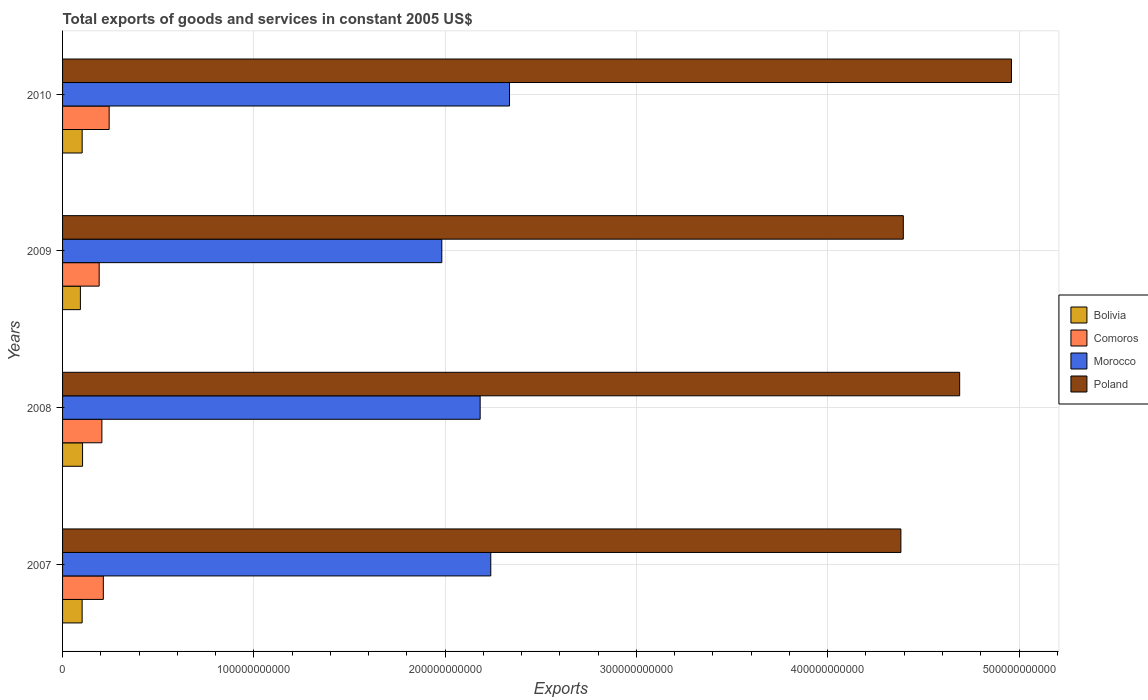How many different coloured bars are there?
Provide a short and direct response. 4. Are the number of bars per tick equal to the number of legend labels?
Offer a terse response. Yes. Are the number of bars on each tick of the Y-axis equal?
Make the answer very short. Yes. What is the label of the 3rd group of bars from the top?
Keep it short and to the point. 2008. What is the total exports of goods and services in Comoros in 2009?
Offer a very short reply. 1.91e+1. Across all years, what is the maximum total exports of goods and services in Comoros?
Give a very brief answer. 2.44e+1. Across all years, what is the minimum total exports of goods and services in Poland?
Keep it short and to the point. 4.38e+11. In which year was the total exports of goods and services in Comoros minimum?
Provide a short and direct response. 2009. What is the total total exports of goods and services in Bolivia in the graph?
Offer a very short reply. 4.03e+1. What is the difference between the total exports of goods and services in Bolivia in 2007 and that in 2008?
Your answer should be compact. -2.22e+08. What is the difference between the total exports of goods and services in Comoros in 2010 and the total exports of goods and services in Bolivia in 2007?
Provide a short and direct response. 1.41e+1. What is the average total exports of goods and services in Comoros per year?
Give a very brief answer. 2.13e+1. In the year 2010, what is the difference between the total exports of goods and services in Morocco and total exports of goods and services in Poland?
Offer a terse response. -2.62e+11. In how many years, is the total exports of goods and services in Poland greater than 160000000000 US$?
Give a very brief answer. 4. What is the ratio of the total exports of goods and services in Morocco in 2007 to that in 2009?
Make the answer very short. 1.13. Is the total exports of goods and services in Poland in 2007 less than that in 2010?
Ensure brevity in your answer.  Yes. Is the difference between the total exports of goods and services in Morocco in 2008 and 2009 greater than the difference between the total exports of goods and services in Poland in 2008 and 2009?
Ensure brevity in your answer.  No. What is the difference between the highest and the second highest total exports of goods and services in Bolivia?
Offer a terse response. 2.05e+08. What is the difference between the highest and the lowest total exports of goods and services in Comoros?
Your answer should be very brief. 5.22e+09. In how many years, is the total exports of goods and services in Morocco greater than the average total exports of goods and services in Morocco taken over all years?
Make the answer very short. 2. Is it the case that in every year, the sum of the total exports of goods and services in Bolivia and total exports of goods and services in Poland is greater than the sum of total exports of goods and services in Comoros and total exports of goods and services in Morocco?
Ensure brevity in your answer.  No. What does the 3rd bar from the top in 2009 represents?
Ensure brevity in your answer.  Comoros. What does the 3rd bar from the bottom in 2008 represents?
Your answer should be very brief. Morocco. How many bars are there?
Your response must be concise. 16. How many years are there in the graph?
Give a very brief answer. 4. What is the difference between two consecutive major ticks on the X-axis?
Keep it short and to the point. 1.00e+11. Are the values on the major ticks of X-axis written in scientific E-notation?
Offer a terse response. No. Does the graph contain any zero values?
Your answer should be very brief. No. Where does the legend appear in the graph?
Ensure brevity in your answer.  Center right. How many legend labels are there?
Your answer should be compact. 4. What is the title of the graph?
Keep it short and to the point. Total exports of goods and services in constant 2005 US$. Does "Croatia" appear as one of the legend labels in the graph?
Ensure brevity in your answer.  No. What is the label or title of the X-axis?
Your response must be concise. Exports. What is the label or title of the Y-axis?
Provide a short and direct response. Years. What is the Exports in Bolivia in 2007?
Make the answer very short. 1.02e+1. What is the Exports of Comoros in 2007?
Offer a very short reply. 2.13e+1. What is the Exports in Morocco in 2007?
Offer a terse response. 2.24e+11. What is the Exports in Poland in 2007?
Provide a short and direct response. 4.38e+11. What is the Exports of Bolivia in 2008?
Give a very brief answer. 1.05e+1. What is the Exports of Comoros in 2008?
Offer a very short reply. 2.06e+1. What is the Exports in Morocco in 2008?
Provide a succinct answer. 2.18e+11. What is the Exports of Poland in 2008?
Provide a succinct answer. 4.69e+11. What is the Exports of Bolivia in 2009?
Offer a terse response. 9.33e+09. What is the Exports in Comoros in 2009?
Your answer should be very brief. 1.91e+1. What is the Exports in Morocco in 2009?
Provide a succinct answer. 1.98e+11. What is the Exports of Poland in 2009?
Provide a succinct answer. 4.40e+11. What is the Exports of Bolivia in 2010?
Your response must be concise. 1.02e+1. What is the Exports in Comoros in 2010?
Provide a succinct answer. 2.44e+1. What is the Exports of Morocco in 2010?
Provide a succinct answer. 2.34e+11. What is the Exports in Poland in 2010?
Offer a terse response. 4.96e+11. Across all years, what is the maximum Exports in Bolivia?
Ensure brevity in your answer.  1.05e+1. Across all years, what is the maximum Exports in Comoros?
Offer a terse response. 2.44e+1. Across all years, what is the maximum Exports in Morocco?
Your answer should be very brief. 2.34e+11. Across all years, what is the maximum Exports in Poland?
Provide a succinct answer. 4.96e+11. Across all years, what is the minimum Exports of Bolivia?
Make the answer very short. 9.33e+09. Across all years, what is the minimum Exports of Comoros?
Your answer should be compact. 1.91e+1. Across all years, what is the minimum Exports in Morocco?
Your answer should be compact. 1.98e+11. Across all years, what is the minimum Exports of Poland?
Offer a very short reply. 4.38e+11. What is the total Exports of Bolivia in the graph?
Make the answer very short. 4.03e+1. What is the total Exports of Comoros in the graph?
Give a very brief answer. 8.54e+1. What is the total Exports in Morocco in the graph?
Keep it short and to the point. 8.74e+11. What is the total Exports in Poland in the graph?
Give a very brief answer. 1.84e+12. What is the difference between the Exports of Bolivia in 2007 and that in 2008?
Offer a very short reply. -2.22e+08. What is the difference between the Exports of Comoros in 2007 and that in 2008?
Ensure brevity in your answer.  7.52e+08. What is the difference between the Exports in Morocco in 2007 and that in 2008?
Your answer should be very brief. 5.55e+09. What is the difference between the Exports of Poland in 2007 and that in 2008?
Your response must be concise. -3.07e+1. What is the difference between the Exports in Bolivia in 2007 and that in 2009?
Offer a terse response. 9.02e+08. What is the difference between the Exports in Comoros in 2007 and that in 2009?
Give a very brief answer. 2.17e+09. What is the difference between the Exports in Morocco in 2007 and that in 2009?
Offer a very short reply. 2.56e+1. What is the difference between the Exports in Poland in 2007 and that in 2009?
Provide a succinct answer. -1.27e+09. What is the difference between the Exports in Bolivia in 2007 and that in 2010?
Keep it short and to the point. -1.73e+07. What is the difference between the Exports of Comoros in 2007 and that in 2010?
Offer a very short reply. -3.05e+09. What is the difference between the Exports of Morocco in 2007 and that in 2010?
Your response must be concise. -9.80e+09. What is the difference between the Exports in Poland in 2007 and that in 2010?
Your response must be concise. -5.78e+1. What is the difference between the Exports in Bolivia in 2008 and that in 2009?
Make the answer very short. 1.12e+09. What is the difference between the Exports of Comoros in 2008 and that in 2009?
Your answer should be very brief. 1.42e+09. What is the difference between the Exports of Morocco in 2008 and that in 2009?
Make the answer very short. 2.00e+1. What is the difference between the Exports of Poland in 2008 and that in 2009?
Provide a succinct answer. 2.95e+1. What is the difference between the Exports in Bolivia in 2008 and that in 2010?
Make the answer very short. 2.05e+08. What is the difference between the Exports in Comoros in 2008 and that in 2010?
Your response must be concise. -3.80e+09. What is the difference between the Exports in Morocco in 2008 and that in 2010?
Provide a succinct answer. -1.53e+1. What is the difference between the Exports in Poland in 2008 and that in 2010?
Offer a terse response. -2.71e+1. What is the difference between the Exports in Bolivia in 2009 and that in 2010?
Provide a succinct answer. -9.19e+08. What is the difference between the Exports in Comoros in 2009 and that in 2010?
Provide a succinct answer. -5.22e+09. What is the difference between the Exports of Morocco in 2009 and that in 2010?
Give a very brief answer. -3.54e+1. What is the difference between the Exports in Poland in 2009 and that in 2010?
Keep it short and to the point. -5.65e+1. What is the difference between the Exports in Bolivia in 2007 and the Exports in Comoros in 2008?
Your answer should be very brief. -1.03e+1. What is the difference between the Exports of Bolivia in 2007 and the Exports of Morocco in 2008?
Keep it short and to the point. -2.08e+11. What is the difference between the Exports in Bolivia in 2007 and the Exports in Poland in 2008?
Make the answer very short. -4.59e+11. What is the difference between the Exports of Comoros in 2007 and the Exports of Morocco in 2008?
Give a very brief answer. -1.97e+11. What is the difference between the Exports of Comoros in 2007 and the Exports of Poland in 2008?
Offer a terse response. -4.48e+11. What is the difference between the Exports of Morocco in 2007 and the Exports of Poland in 2008?
Make the answer very short. -2.45e+11. What is the difference between the Exports of Bolivia in 2007 and the Exports of Comoros in 2009?
Make the answer very short. -8.91e+09. What is the difference between the Exports of Bolivia in 2007 and the Exports of Morocco in 2009?
Provide a succinct answer. -1.88e+11. What is the difference between the Exports of Bolivia in 2007 and the Exports of Poland in 2009?
Your answer should be very brief. -4.29e+11. What is the difference between the Exports of Comoros in 2007 and the Exports of Morocco in 2009?
Keep it short and to the point. -1.77e+11. What is the difference between the Exports of Comoros in 2007 and the Exports of Poland in 2009?
Provide a succinct answer. -4.18e+11. What is the difference between the Exports in Morocco in 2007 and the Exports in Poland in 2009?
Ensure brevity in your answer.  -2.16e+11. What is the difference between the Exports in Bolivia in 2007 and the Exports in Comoros in 2010?
Your response must be concise. -1.41e+1. What is the difference between the Exports in Bolivia in 2007 and the Exports in Morocco in 2010?
Your response must be concise. -2.23e+11. What is the difference between the Exports in Bolivia in 2007 and the Exports in Poland in 2010?
Give a very brief answer. -4.86e+11. What is the difference between the Exports of Comoros in 2007 and the Exports of Morocco in 2010?
Your answer should be very brief. -2.12e+11. What is the difference between the Exports of Comoros in 2007 and the Exports of Poland in 2010?
Your answer should be very brief. -4.75e+11. What is the difference between the Exports in Morocco in 2007 and the Exports in Poland in 2010?
Offer a terse response. -2.72e+11. What is the difference between the Exports of Bolivia in 2008 and the Exports of Comoros in 2009?
Your answer should be compact. -8.68e+09. What is the difference between the Exports of Bolivia in 2008 and the Exports of Morocco in 2009?
Your answer should be very brief. -1.88e+11. What is the difference between the Exports in Bolivia in 2008 and the Exports in Poland in 2009?
Keep it short and to the point. -4.29e+11. What is the difference between the Exports of Comoros in 2008 and the Exports of Morocco in 2009?
Provide a short and direct response. -1.78e+11. What is the difference between the Exports in Comoros in 2008 and the Exports in Poland in 2009?
Your answer should be very brief. -4.19e+11. What is the difference between the Exports of Morocco in 2008 and the Exports of Poland in 2009?
Provide a succinct answer. -2.21e+11. What is the difference between the Exports in Bolivia in 2008 and the Exports in Comoros in 2010?
Keep it short and to the point. -1.39e+1. What is the difference between the Exports of Bolivia in 2008 and the Exports of Morocco in 2010?
Offer a very short reply. -2.23e+11. What is the difference between the Exports in Bolivia in 2008 and the Exports in Poland in 2010?
Ensure brevity in your answer.  -4.86e+11. What is the difference between the Exports of Comoros in 2008 and the Exports of Morocco in 2010?
Ensure brevity in your answer.  -2.13e+11. What is the difference between the Exports in Comoros in 2008 and the Exports in Poland in 2010?
Keep it short and to the point. -4.76e+11. What is the difference between the Exports in Morocco in 2008 and the Exports in Poland in 2010?
Your response must be concise. -2.78e+11. What is the difference between the Exports of Bolivia in 2009 and the Exports of Comoros in 2010?
Offer a terse response. -1.50e+1. What is the difference between the Exports in Bolivia in 2009 and the Exports in Morocco in 2010?
Make the answer very short. -2.24e+11. What is the difference between the Exports of Bolivia in 2009 and the Exports of Poland in 2010?
Your answer should be very brief. -4.87e+11. What is the difference between the Exports in Comoros in 2009 and the Exports in Morocco in 2010?
Offer a terse response. -2.15e+11. What is the difference between the Exports in Comoros in 2009 and the Exports in Poland in 2010?
Your answer should be very brief. -4.77e+11. What is the difference between the Exports in Morocco in 2009 and the Exports in Poland in 2010?
Offer a terse response. -2.98e+11. What is the average Exports of Bolivia per year?
Provide a succinct answer. 1.01e+1. What is the average Exports of Comoros per year?
Ensure brevity in your answer.  2.13e+1. What is the average Exports of Morocco per year?
Keep it short and to the point. 2.19e+11. What is the average Exports of Poland per year?
Make the answer very short. 4.61e+11. In the year 2007, what is the difference between the Exports of Bolivia and Exports of Comoros?
Offer a very short reply. -1.11e+1. In the year 2007, what is the difference between the Exports in Bolivia and Exports in Morocco?
Offer a terse response. -2.14e+11. In the year 2007, what is the difference between the Exports in Bolivia and Exports in Poland?
Give a very brief answer. -4.28e+11. In the year 2007, what is the difference between the Exports of Comoros and Exports of Morocco?
Offer a very short reply. -2.03e+11. In the year 2007, what is the difference between the Exports in Comoros and Exports in Poland?
Your answer should be very brief. -4.17e+11. In the year 2007, what is the difference between the Exports of Morocco and Exports of Poland?
Make the answer very short. -2.14e+11. In the year 2008, what is the difference between the Exports of Bolivia and Exports of Comoros?
Ensure brevity in your answer.  -1.01e+1. In the year 2008, what is the difference between the Exports of Bolivia and Exports of Morocco?
Your response must be concise. -2.08e+11. In the year 2008, what is the difference between the Exports of Bolivia and Exports of Poland?
Your answer should be very brief. -4.59e+11. In the year 2008, what is the difference between the Exports of Comoros and Exports of Morocco?
Ensure brevity in your answer.  -1.98e+11. In the year 2008, what is the difference between the Exports of Comoros and Exports of Poland?
Ensure brevity in your answer.  -4.48e+11. In the year 2008, what is the difference between the Exports of Morocco and Exports of Poland?
Ensure brevity in your answer.  -2.51e+11. In the year 2009, what is the difference between the Exports in Bolivia and Exports in Comoros?
Your answer should be very brief. -9.81e+09. In the year 2009, what is the difference between the Exports of Bolivia and Exports of Morocco?
Your response must be concise. -1.89e+11. In the year 2009, what is the difference between the Exports of Bolivia and Exports of Poland?
Give a very brief answer. -4.30e+11. In the year 2009, what is the difference between the Exports of Comoros and Exports of Morocco?
Provide a short and direct response. -1.79e+11. In the year 2009, what is the difference between the Exports in Comoros and Exports in Poland?
Your answer should be compact. -4.20e+11. In the year 2009, what is the difference between the Exports in Morocco and Exports in Poland?
Provide a succinct answer. -2.41e+11. In the year 2010, what is the difference between the Exports in Bolivia and Exports in Comoros?
Make the answer very short. -1.41e+1. In the year 2010, what is the difference between the Exports of Bolivia and Exports of Morocco?
Offer a terse response. -2.23e+11. In the year 2010, what is the difference between the Exports in Bolivia and Exports in Poland?
Offer a terse response. -4.86e+11. In the year 2010, what is the difference between the Exports in Comoros and Exports in Morocco?
Your response must be concise. -2.09e+11. In the year 2010, what is the difference between the Exports of Comoros and Exports of Poland?
Make the answer very short. -4.72e+11. In the year 2010, what is the difference between the Exports of Morocco and Exports of Poland?
Keep it short and to the point. -2.62e+11. What is the ratio of the Exports of Bolivia in 2007 to that in 2008?
Provide a succinct answer. 0.98. What is the ratio of the Exports of Comoros in 2007 to that in 2008?
Make the answer very short. 1.04. What is the ratio of the Exports of Morocco in 2007 to that in 2008?
Make the answer very short. 1.03. What is the ratio of the Exports of Poland in 2007 to that in 2008?
Make the answer very short. 0.93. What is the ratio of the Exports of Bolivia in 2007 to that in 2009?
Give a very brief answer. 1.1. What is the ratio of the Exports in Comoros in 2007 to that in 2009?
Your answer should be very brief. 1.11. What is the ratio of the Exports in Morocco in 2007 to that in 2009?
Ensure brevity in your answer.  1.13. What is the ratio of the Exports of Comoros in 2007 to that in 2010?
Your answer should be compact. 0.87. What is the ratio of the Exports of Morocco in 2007 to that in 2010?
Keep it short and to the point. 0.96. What is the ratio of the Exports in Poland in 2007 to that in 2010?
Keep it short and to the point. 0.88. What is the ratio of the Exports in Bolivia in 2008 to that in 2009?
Make the answer very short. 1.12. What is the ratio of the Exports of Comoros in 2008 to that in 2009?
Make the answer very short. 1.07. What is the ratio of the Exports of Morocco in 2008 to that in 2009?
Provide a succinct answer. 1.1. What is the ratio of the Exports in Poland in 2008 to that in 2009?
Offer a terse response. 1.07. What is the ratio of the Exports in Comoros in 2008 to that in 2010?
Offer a very short reply. 0.84. What is the ratio of the Exports in Morocco in 2008 to that in 2010?
Your answer should be compact. 0.93. What is the ratio of the Exports of Poland in 2008 to that in 2010?
Offer a very short reply. 0.95. What is the ratio of the Exports in Bolivia in 2009 to that in 2010?
Your answer should be very brief. 0.91. What is the ratio of the Exports of Comoros in 2009 to that in 2010?
Give a very brief answer. 0.79. What is the ratio of the Exports of Morocco in 2009 to that in 2010?
Give a very brief answer. 0.85. What is the ratio of the Exports of Poland in 2009 to that in 2010?
Offer a very short reply. 0.89. What is the difference between the highest and the second highest Exports in Bolivia?
Your answer should be very brief. 2.05e+08. What is the difference between the highest and the second highest Exports in Comoros?
Provide a succinct answer. 3.05e+09. What is the difference between the highest and the second highest Exports in Morocco?
Your answer should be compact. 9.80e+09. What is the difference between the highest and the second highest Exports of Poland?
Ensure brevity in your answer.  2.71e+1. What is the difference between the highest and the lowest Exports of Bolivia?
Make the answer very short. 1.12e+09. What is the difference between the highest and the lowest Exports of Comoros?
Ensure brevity in your answer.  5.22e+09. What is the difference between the highest and the lowest Exports in Morocco?
Provide a succinct answer. 3.54e+1. What is the difference between the highest and the lowest Exports in Poland?
Provide a succinct answer. 5.78e+1. 